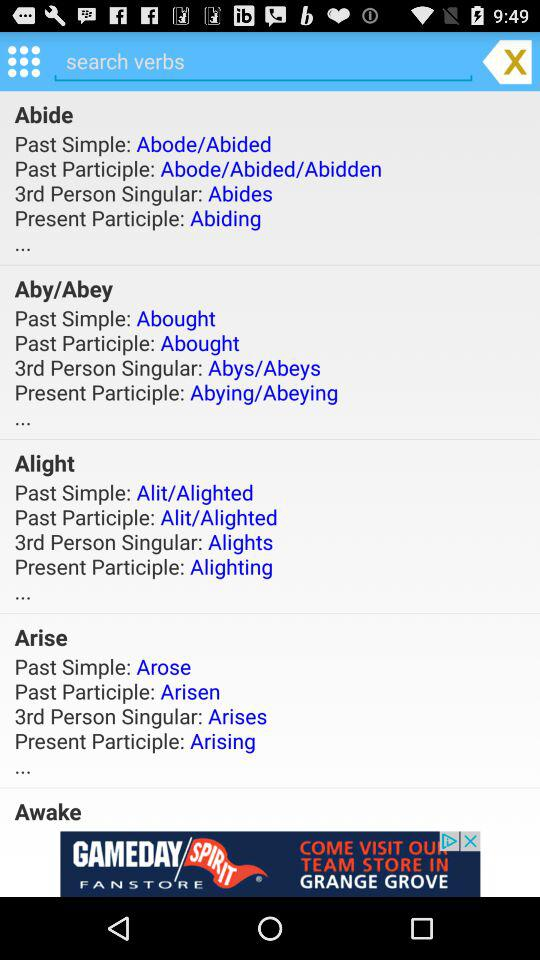What is the past participle of Abey? The past participle is Abought. 